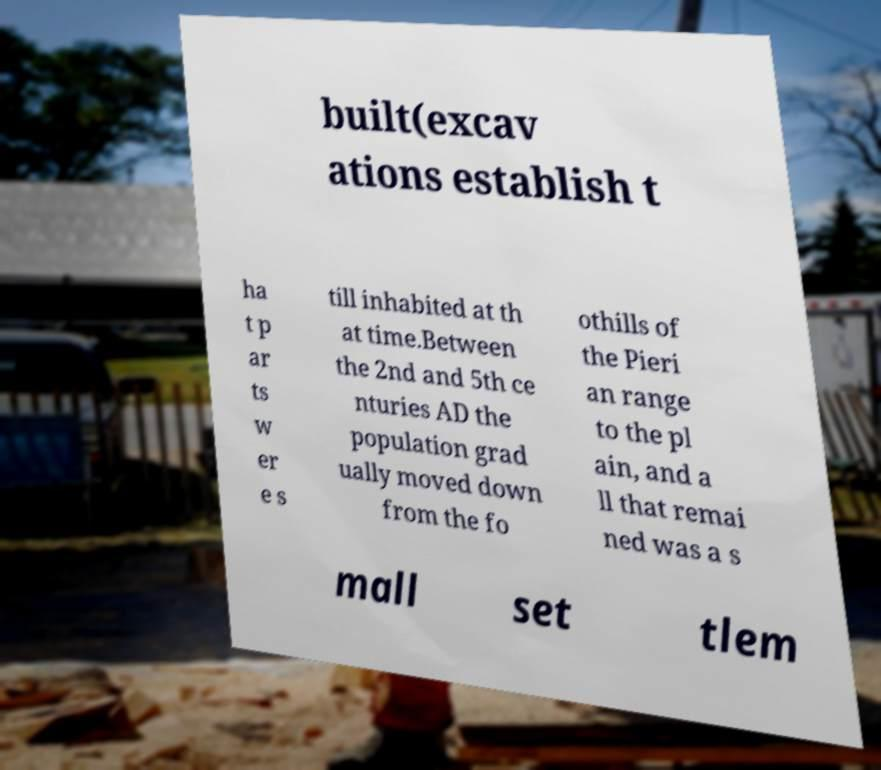Can you read and provide the text displayed in the image?This photo seems to have some interesting text. Can you extract and type it out for me? built(excav ations establish t ha t p ar ts w er e s till inhabited at th at time.Between the 2nd and 5th ce nturies AD the population grad ually moved down from the fo othills of the Pieri an range to the pl ain, and a ll that remai ned was a s mall set tlem 